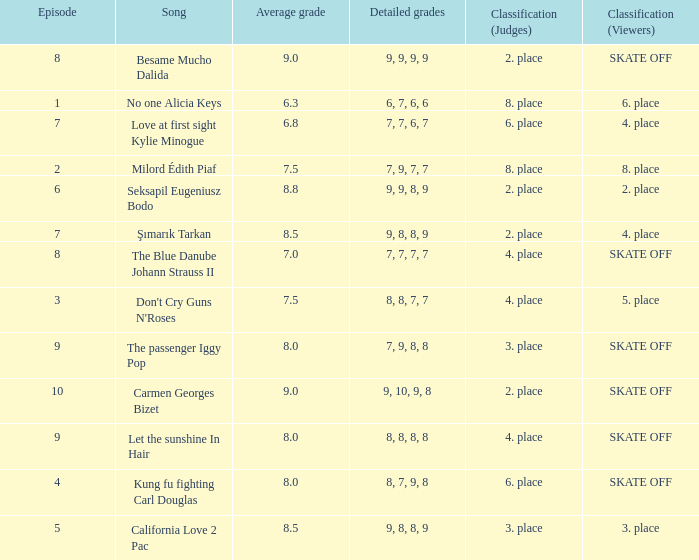Name the classification for 9, 9, 8, 9 2. place. 